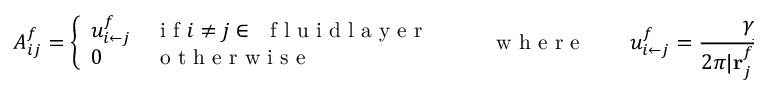<formula> <loc_0><loc_0><loc_500><loc_500>A _ { i j } ^ { f } = \left \{ \begin{array} { l l } { u _ { { i } \leftarrow { j } } ^ { f } } & { i f i \neq j \in f l u i d l a y e r } \\ { 0 } & { o t h e r w i s e } \end{array} \quad w h e r e \quad u _ { i \leftarrow j } ^ { f } = \frac { \gamma _ { j } ^ { f } } { 2 \pi | r _ { j } ^ { f } - r _ { i } ^ { f } | } .</formula> 